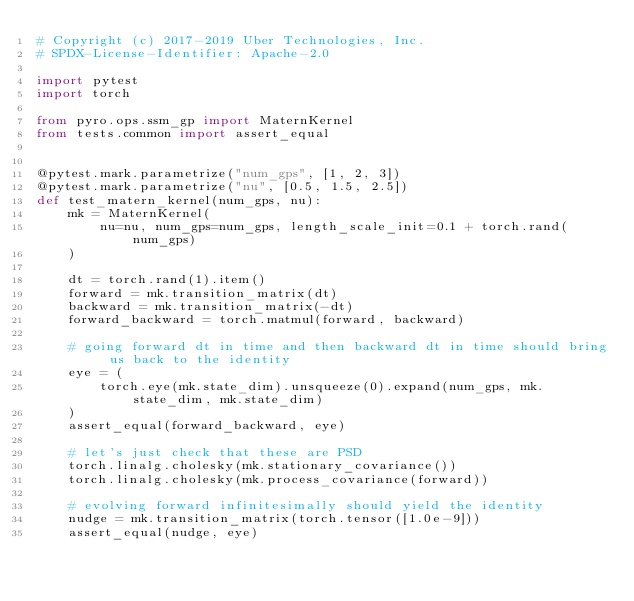<code> <loc_0><loc_0><loc_500><loc_500><_Python_># Copyright (c) 2017-2019 Uber Technologies, Inc.
# SPDX-License-Identifier: Apache-2.0

import pytest
import torch

from pyro.ops.ssm_gp import MaternKernel
from tests.common import assert_equal


@pytest.mark.parametrize("num_gps", [1, 2, 3])
@pytest.mark.parametrize("nu", [0.5, 1.5, 2.5])
def test_matern_kernel(num_gps, nu):
    mk = MaternKernel(
        nu=nu, num_gps=num_gps, length_scale_init=0.1 + torch.rand(num_gps)
    )

    dt = torch.rand(1).item()
    forward = mk.transition_matrix(dt)
    backward = mk.transition_matrix(-dt)
    forward_backward = torch.matmul(forward, backward)

    # going forward dt in time and then backward dt in time should bring us back to the identity
    eye = (
        torch.eye(mk.state_dim).unsqueeze(0).expand(num_gps, mk.state_dim, mk.state_dim)
    )
    assert_equal(forward_backward, eye)

    # let's just check that these are PSD
    torch.linalg.cholesky(mk.stationary_covariance())
    torch.linalg.cholesky(mk.process_covariance(forward))

    # evolving forward infinitesimally should yield the identity
    nudge = mk.transition_matrix(torch.tensor([1.0e-9]))
    assert_equal(nudge, eye)
</code> 